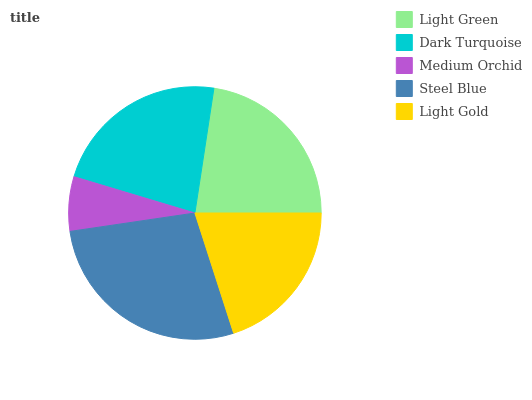Is Medium Orchid the minimum?
Answer yes or no. Yes. Is Steel Blue the maximum?
Answer yes or no. Yes. Is Dark Turquoise the minimum?
Answer yes or no. No. Is Dark Turquoise the maximum?
Answer yes or no. No. Is Dark Turquoise greater than Light Green?
Answer yes or no. Yes. Is Light Green less than Dark Turquoise?
Answer yes or no. Yes. Is Light Green greater than Dark Turquoise?
Answer yes or no. No. Is Dark Turquoise less than Light Green?
Answer yes or no. No. Is Light Green the high median?
Answer yes or no. Yes. Is Light Green the low median?
Answer yes or no. Yes. Is Light Gold the high median?
Answer yes or no. No. Is Dark Turquoise the low median?
Answer yes or no. No. 